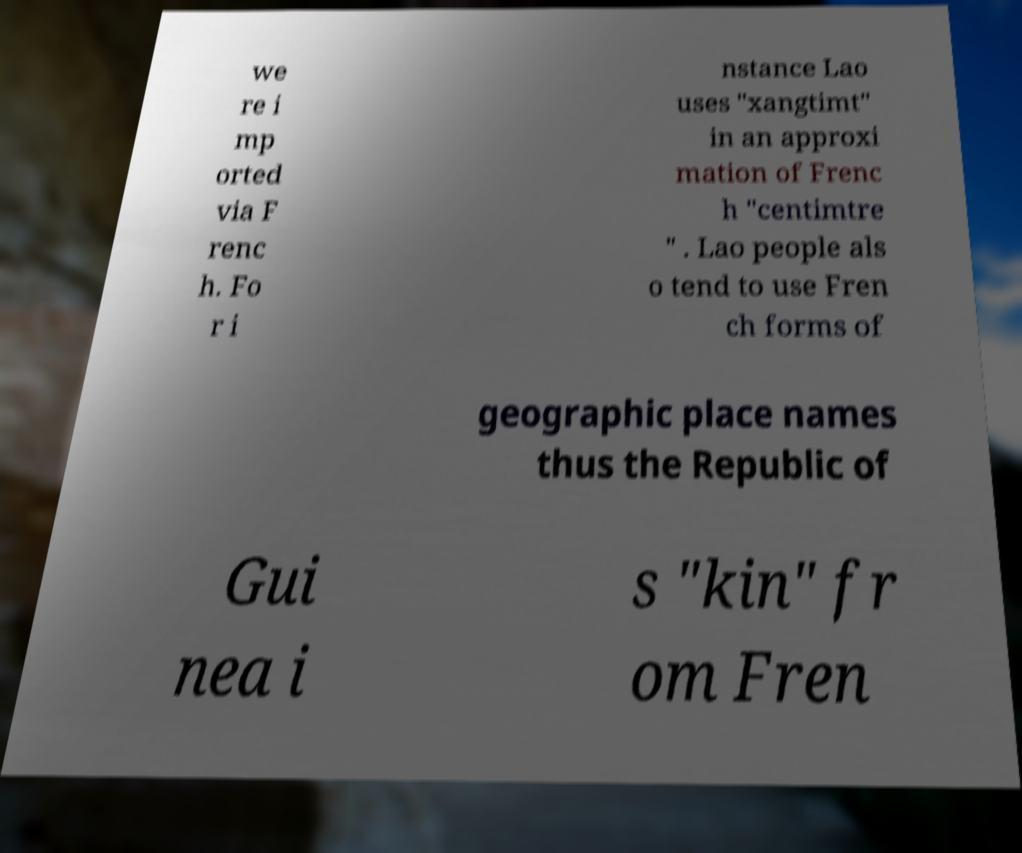I need the written content from this picture converted into text. Can you do that? we re i mp orted via F renc h. Fo r i nstance Lao uses "xangtimt" in an approxi mation of Frenc h "centimtre " . Lao people als o tend to use Fren ch forms of geographic place names thus the Republic of Gui nea i s "kin" fr om Fren 